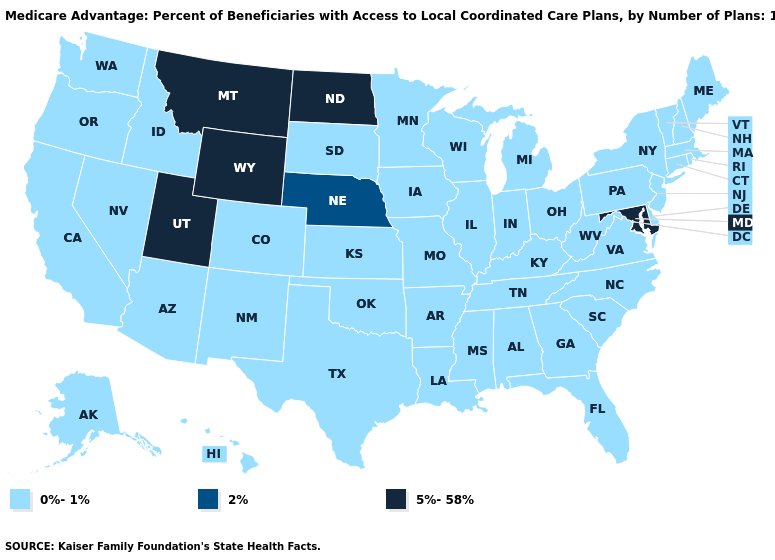What is the value of Pennsylvania?
Keep it brief. 0%-1%. What is the highest value in the MidWest ?
Give a very brief answer. 5%-58%. Does Wisconsin have the same value as New Jersey?
Give a very brief answer. Yes. Does Maryland have the lowest value in the USA?
Short answer required. No. Does the first symbol in the legend represent the smallest category?
Be succinct. Yes. Among the states that border Nevada , does California have the highest value?
Answer briefly. No. What is the value of Wisconsin?
Give a very brief answer. 0%-1%. Is the legend a continuous bar?
Answer briefly. No. Is the legend a continuous bar?
Concise answer only. No. Which states have the lowest value in the USA?
Short answer required. Alabama, Alaska, Arizona, Arkansas, California, Colorado, Connecticut, Delaware, Florida, Georgia, Hawaii, Idaho, Illinois, Indiana, Iowa, Kansas, Kentucky, Louisiana, Maine, Massachusetts, Michigan, Minnesota, Mississippi, Missouri, Nevada, New Hampshire, New Jersey, New Mexico, New York, North Carolina, Ohio, Oklahoma, Oregon, Pennsylvania, Rhode Island, South Carolina, South Dakota, Tennessee, Texas, Vermont, Virginia, Washington, West Virginia, Wisconsin. What is the lowest value in the USA?
Quick response, please. 0%-1%. What is the highest value in the Northeast ?
Keep it brief. 0%-1%. 